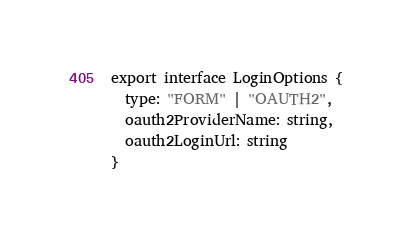Convert code to text. <code><loc_0><loc_0><loc_500><loc_500><_TypeScript_>export interface LoginOptions {
  type: "FORM" | "OAUTH2",
  oauth2ProviderName: string,
  oauth2LoginUrl: string
}
</code> 